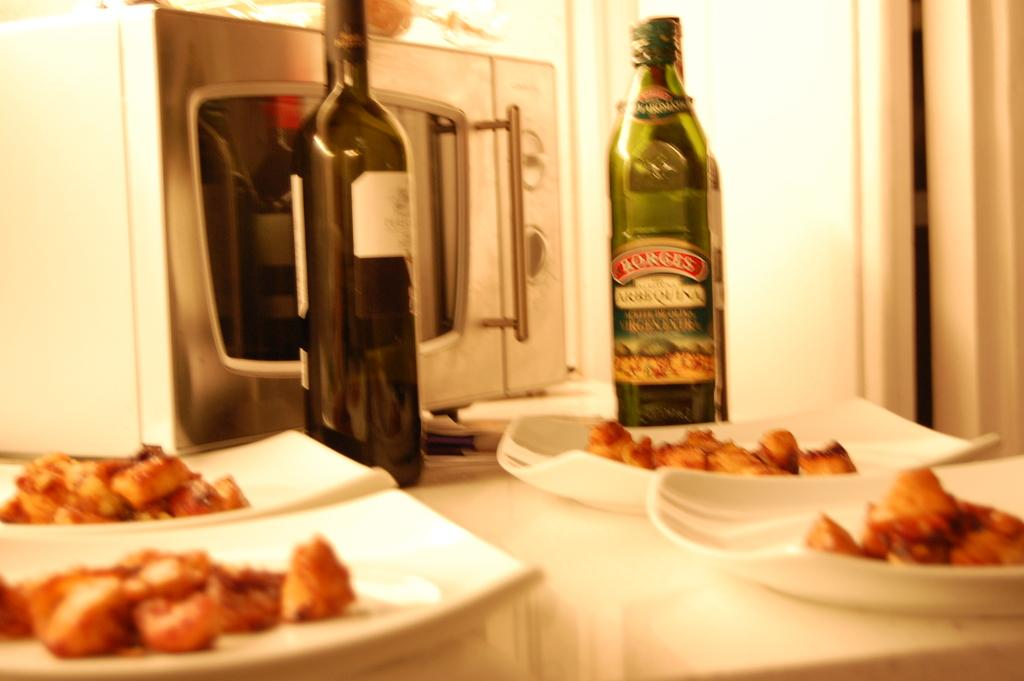How many wine bottles are visible in the image? There are two wine bottles in the image. What type of appliance can be seen in the image? There is a microwave oven in the image. What else is present on the table in the image? There are eatables present in the image. Where are all these objects placed in the image? All of these objects are placed on a table. How does the goose transport the wine bottles in the image? There is no goose present in the image, and therefore no such activity can be observed. What causes the microwave oven to burst in the image? The microwave oven does not burst in the image; it is a stationary appliance. 